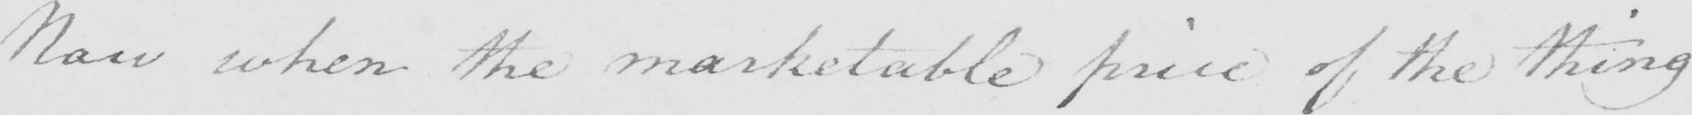What does this handwritten line say? Now when the marketable price of the thing 